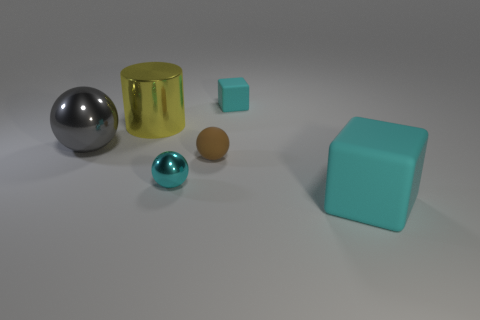Subtract all shiny spheres. How many spheres are left? 1 Subtract all brown spheres. How many spheres are left? 2 Subtract all red cylinders. How many brown blocks are left? 0 Add 2 small red rubber cylinders. How many small red rubber cylinders exist? 2 Add 2 small green rubber cylinders. How many objects exist? 8 Subtract 0 blue blocks. How many objects are left? 6 Subtract all cubes. How many objects are left? 4 Subtract 2 blocks. How many blocks are left? 0 Subtract all red blocks. Subtract all brown balls. How many blocks are left? 2 Subtract all cylinders. Subtract all big gray balls. How many objects are left? 4 